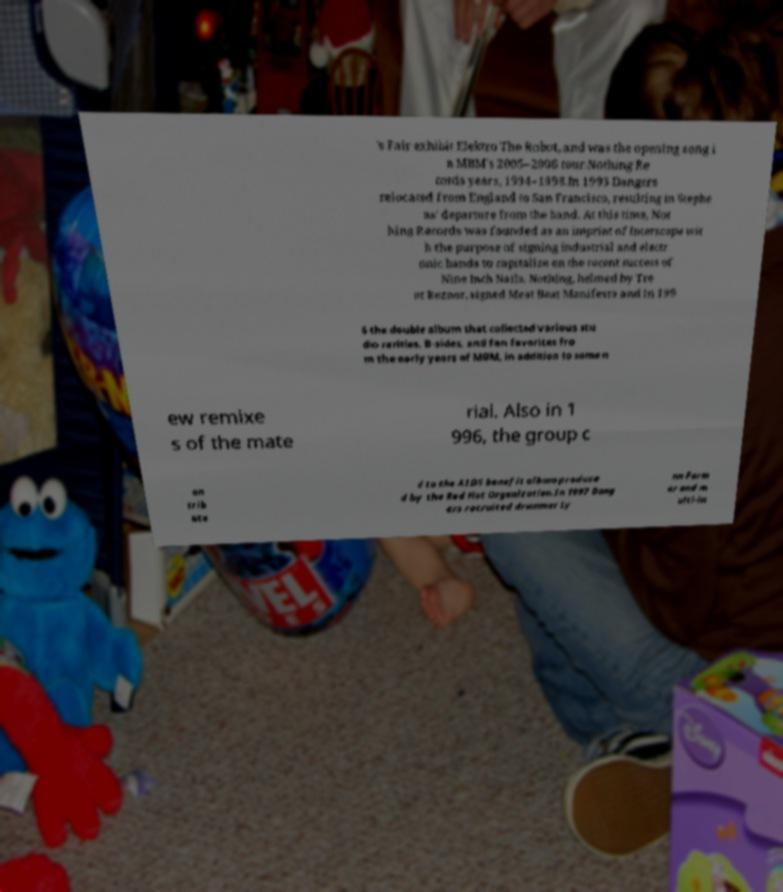Can you accurately transcribe the text from the provided image for me? 's Fair exhibit Elektro The Robot, and was the opening song i n MBM's 2005–2006 tour.Nothing Re cords years, 1994–1998.In 1993 Dangers relocated from England to San Francisco, resulting in Stephe ns' departure from the band. At this time, Not hing Records was founded as an imprint of Interscope wit h the purpose of signing industrial and electr onic bands to capitalize on the recent success of Nine Inch Nails. Nothing, helmed by Tre nt Reznor, signed Meat Beat Manifesto and in 199 6 the double album that collected various stu dio rarities, B-sides, and fan favorites fro m the early years of MBM, in addition to some n ew remixe s of the mate rial. Also in 1 996, the group c on trib ute d to the AIDS benefit album produce d by the Red Hot Organization.In 1997 Dang ers recruited drummer Ly nn Farm er and m ulti-in 